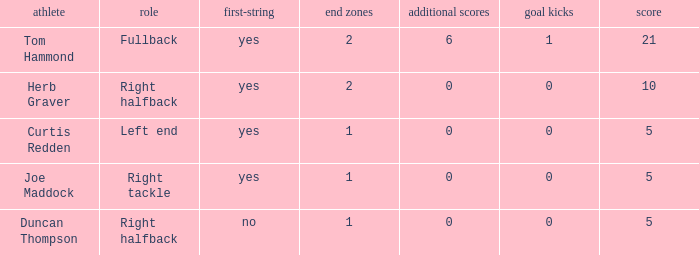Could you help me parse every detail presented in this table? {'header': ['athlete', 'role', 'first-string', 'end zones', 'additional scores', 'goal kicks', 'score'], 'rows': [['Tom Hammond', 'Fullback', 'yes', '2', '6', '1', '21'], ['Herb Graver', 'Right halfback', 'yes', '2', '0', '0', '10'], ['Curtis Redden', 'Left end', 'yes', '1', '0', '0', '5'], ['Joe Maddock', 'Right tackle', 'yes', '1', '0', '0', '5'], ['Duncan Thompson', 'Right halfback', 'no', '1', '0', '0', '5']]} Indicate the lowest touchdowns 1.0. 